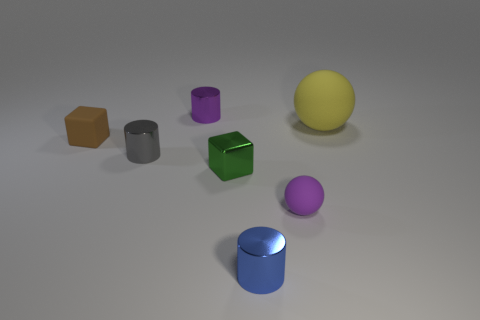There is a object that is both behind the small green shiny block and in front of the brown cube; what is its shape? The object fitting that description has a cylindrical shape. It's a vertical cylinder with a purple color, positioned directly behind the green cube and in front of the brown cube in view. 